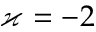Convert formula to latex. <formula><loc_0><loc_0><loc_500><loc_500>\varkappa = - 2</formula> 